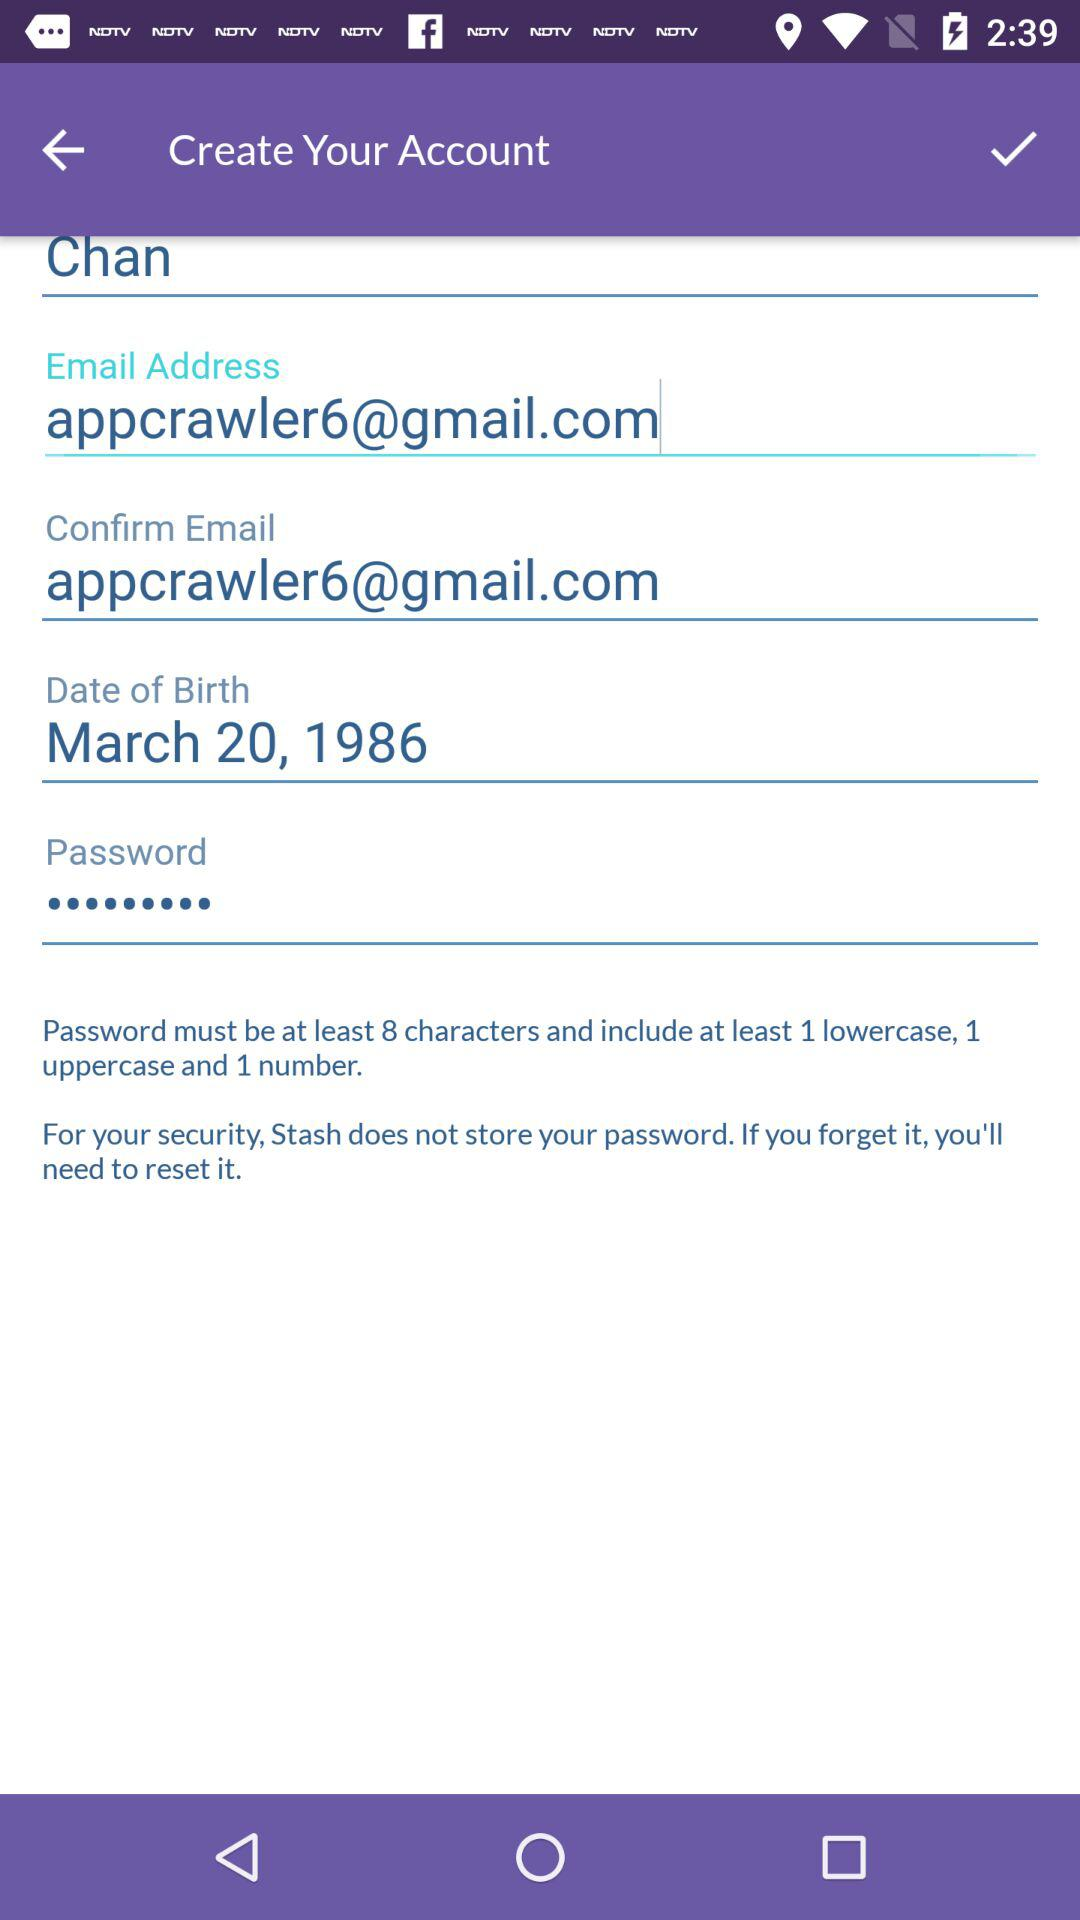What is the user name? The user name is Chan. 